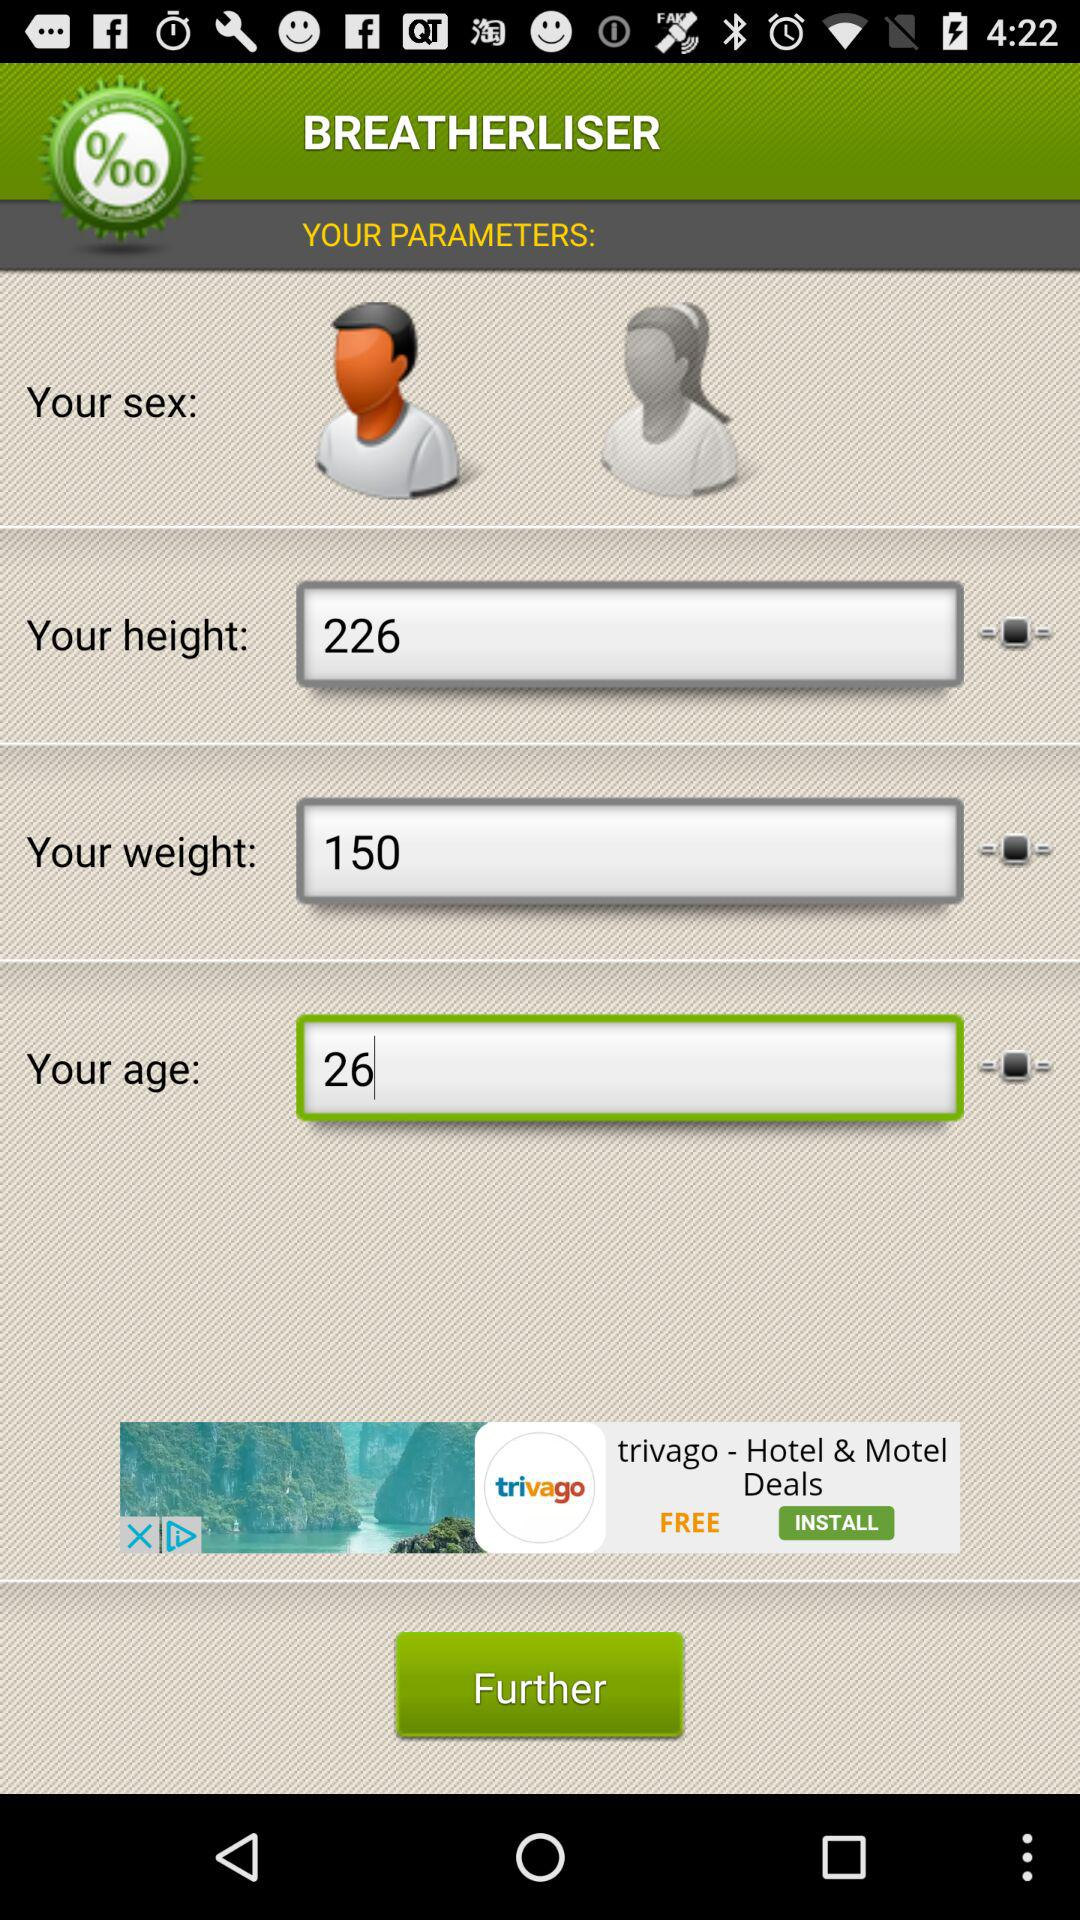What is the weight? The weight is 150. 